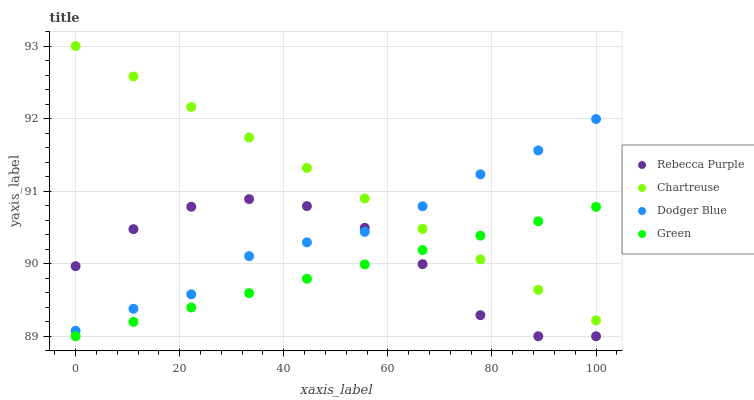Does Green have the minimum area under the curve?
Answer yes or no. Yes. Does Chartreuse have the maximum area under the curve?
Answer yes or no. Yes. Does Dodger Blue have the minimum area under the curve?
Answer yes or no. No. Does Dodger Blue have the maximum area under the curve?
Answer yes or no. No. Is Green the smoothest?
Answer yes or no. Yes. Is Rebecca Purple the roughest?
Answer yes or no. Yes. Is Chartreuse the smoothest?
Answer yes or no. No. Is Chartreuse the roughest?
Answer yes or no. No. Does Green have the lowest value?
Answer yes or no. Yes. Does Dodger Blue have the lowest value?
Answer yes or no. No. Does Chartreuse have the highest value?
Answer yes or no. Yes. Does Dodger Blue have the highest value?
Answer yes or no. No. Is Rebecca Purple less than Chartreuse?
Answer yes or no. Yes. Is Dodger Blue greater than Green?
Answer yes or no. Yes. Does Rebecca Purple intersect Dodger Blue?
Answer yes or no. Yes. Is Rebecca Purple less than Dodger Blue?
Answer yes or no. No. Is Rebecca Purple greater than Dodger Blue?
Answer yes or no. No. Does Rebecca Purple intersect Chartreuse?
Answer yes or no. No. 